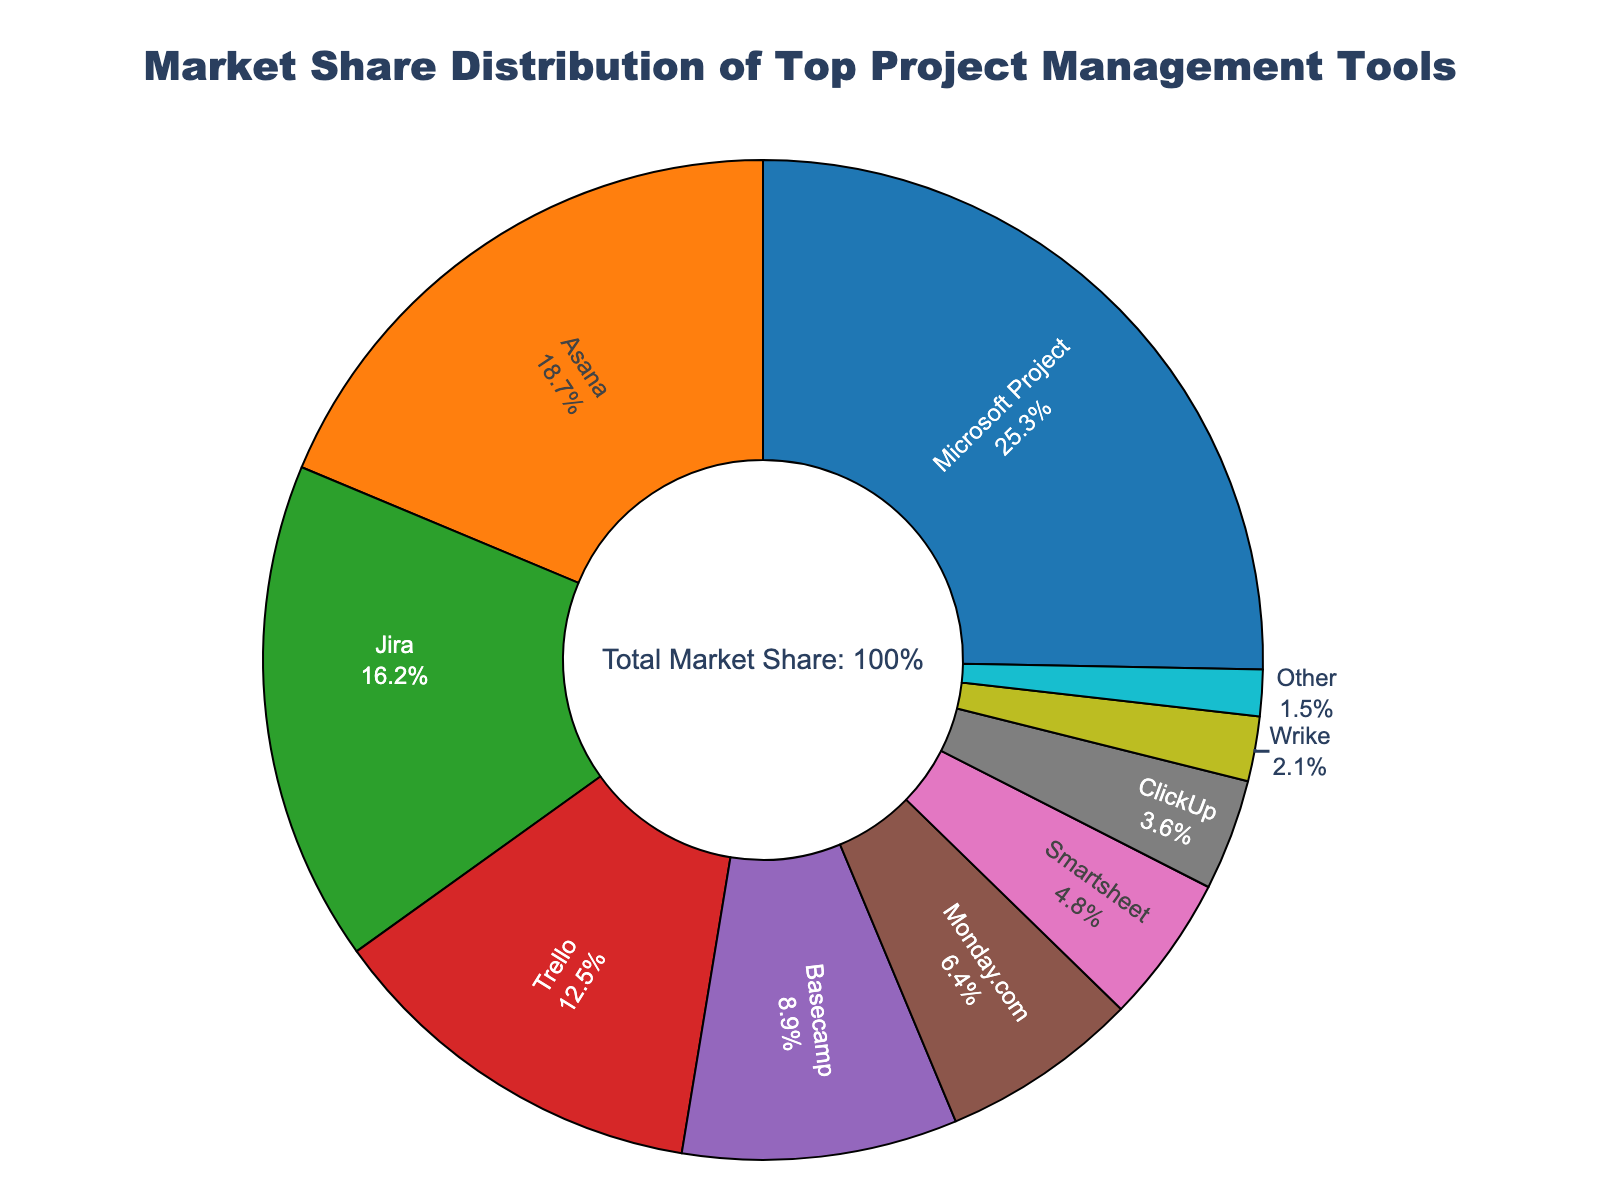What is the market share of the leading project management tool? The leading project management tool is Microsoft Project, which has the highest percentage slice in the pie chart.
Answer: 25.3% What is the combined market share of Asana and Jira? To find the combined market share of Asana and Jira, sum their individual market shares: 18.7% + 16.2%.
Answer: 34.9% Which tool has a market share closest to 10%? Visually inspecting the pie chart, the tool with a market share closest to 10% is Basecamp with 8.9%.
Answer: Basecamp How much greater is Microsoft Project’s market share compared to ClickUp’s? First, find the difference between the market shares of Microsoft Project and ClickUp: 25.3% - 3.6%.
Answer: 21.7% What is the sum of the market shares of the tools with less than 10% market share each? Review the market shares of tools with less than 10%: Basecamp (8.9%), Monday.com (6.4%), Smartsheet (4.8%), ClickUp (3.6%), Wrike (2.1%), Other (1.5%). Sum these up: 8.9% + 6.4% + 4.8% + 3.6% + 2.1% + 1.5%.
Answer: 27.3% How does Trello's market share compare to Monday.com's? Trello's market share (12.5%) is greater than Monday.com's market share (6.4%).
Answer: Trello has a greater market share Which sections of the pie chart are represented by green and red colors? Visually identify the green and red sections in the pie chart. The green section corresponds to Jira and the red section corresponds to Trello.
Answer: Jira and Trello How many tools have a market share of over 15%? Count the pie chart sections with market shares over 15%: Microsoft Project (25.3%), Asana (18.7%), Jira (16.2%).
Answer: 3 Rank the top three project management tools in descending order of market share. Identify the top three tools by their market shares: Microsoft Project (25.3%), Asana (18.7%), Jira (16.2%).
Answer: Microsoft Project, Asana, Jira What is the difference between the market share of Trello and Basecamp? To find the difference between the market shares of Trello and Basecamp: 12.5% - 8.9%.
Answer: 3.6% 